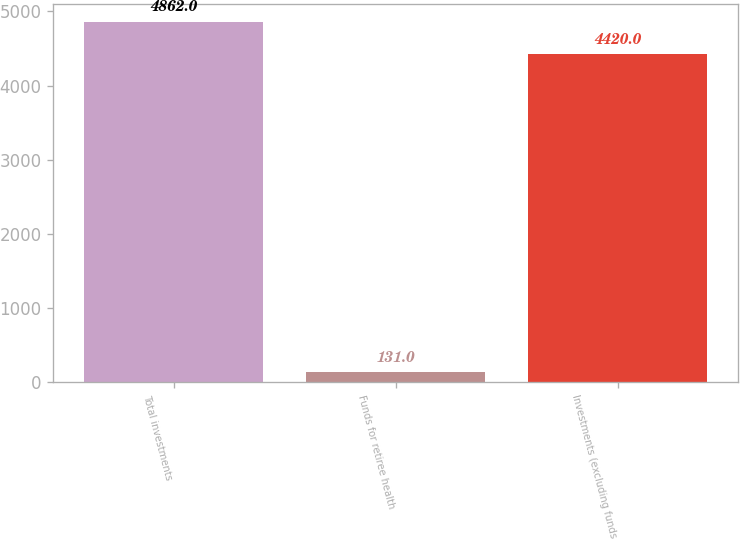<chart> <loc_0><loc_0><loc_500><loc_500><bar_chart><fcel>Total investments<fcel>Funds for retiree health<fcel>Investments (excluding funds<nl><fcel>4862<fcel>131<fcel>4420<nl></chart> 